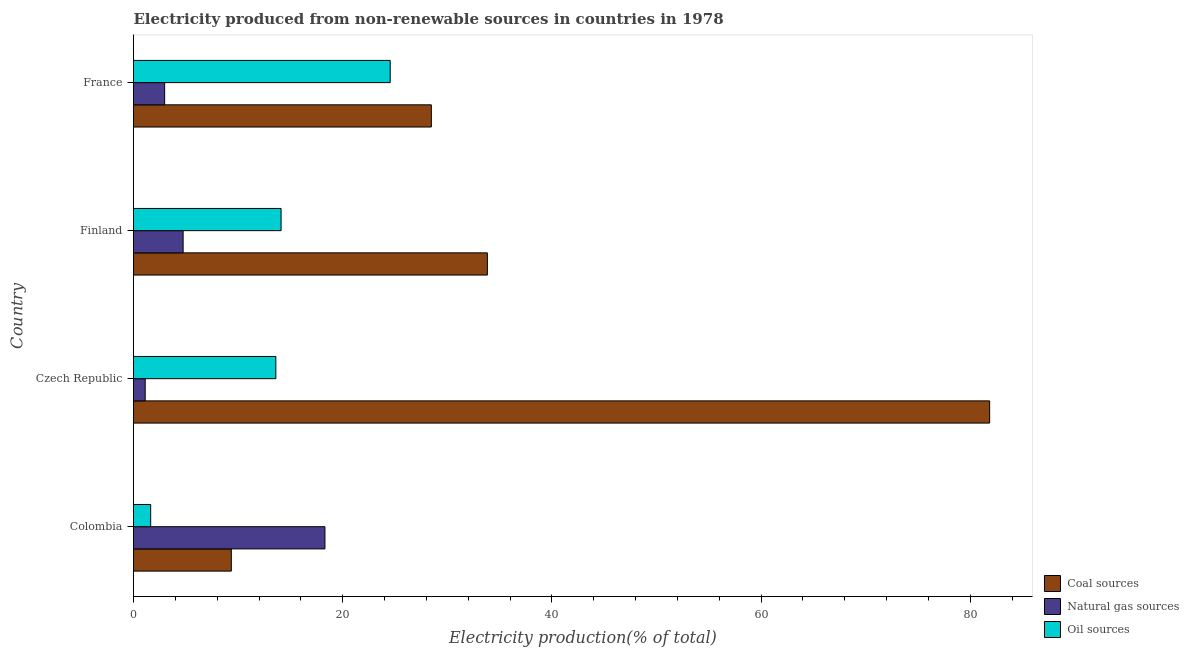How many different coloured bars are there?
Keep it short and to the point. 3. How many groups of bars are there?
Provide a succinct answer. 4. Are the number of bars per tick equal to the number of legend labels?
Keep it short and to the point. Yes. Are the number of bars on each tick of the Y-axis equal?
Ensure brevity in your answer.  Yes. How many bars are there on the 3rd tick from the top?
Offer a terse response. 3. How many bars are there on the 1st tick from the bottom?
Your response must be concise. 3. What is the label of the 1st group of bars from the top?
Offer a terse response. France. What is the percentage of electricity produced by oil sources in France?
Provide a succinct answer. 24.54. Across all countries, what is the maximum percentage of electricity produced by coal?
Ensure brevity in your answer.  81.86. Across all countries, what is the minimum percentage of electricity produced by natural gas?
Your answer should be compact. 1.12. In which country was the percentage of electricity produced by natural gas maximum?
Provide a short and direct response. Colombia. What is the total percentage of electricity produced by coal in the graph?
Offer a terse response. 153.53. What is the difference between the percentage of electricity produced by oil sources in Colombia and that in Czech Republic?
Give a very brief answer. -11.97. What is the difference between the percentage of electricity produced by natural gas in Colombia and the percentage of electricity produced by oil sources in France?
Give a very brief answer. -6.24. What is the average percentage of electricity produced by coal per country?
Your answer should be compact. 38.38. What is the difference between the percentage of electricity produced by oil sources and percentage of electricity produced by coal in Colombia?
Keep it short and to the point. -7.71. What is the ratio of the percentage of electricity produced by oil sources in Czech Republic to that in Finland?
Your response must be concise. 0.96. Is the percentage of electricity produced by natural gas in Colombia less than that in Finland?
Make the answer very short. No. What is the difference between the highest and the second highest percentage of electricity produced by natural gas?
Offer a very short reply. 13.56. What is the difference between the highest and the lowest percentage of electricity produced by coal?
Your answer should be very brief. 72.51. Is the sum of the percentage of electricity produced by oil sources in Colombia and Czech Republic greater than the maximum percentage of electricity produced by natural gas across all countries?
Provide a short and direct response. No. What does the 3rd bar from the top in Finland represents?
Provide a succinct answer. Coal sources. What does the 3rd bar from the bottom in Colombia represents?
Offer a very short reply. Oil sources. Is it the case that in every country, the sum of the percentage of electricity produced by coal and percentage of electricity produced by natural gas is greater than the percentage of electricity produced by oil sources?
Offer a terse response. Yes. What is the difference between two consecutive major ticks on the X-axis?
Provide a succinct answer. 20. Are the values on the major ticks of X-axis written in scientific E-notation?
Your answer should be compact. No. What is the title of the graph?
Offer a terse response. Electricity produced from non-renewable sources in countries in 1978. What is the label or title of the Y-axis?
Your response must be concise. Country. What is the Electricity production(% of total) of Coal sources in Colombia?
Your answer should be compact. 9.35. What is the Electricity production(% of total) in Natural gas sources in Colombia?
Keep it short and to the point. 18.3. What is the Electricity production(% of total) in Oil sources in Colombia?
Keep it short and to the point. 1.64. What is the Electricity production(% of total) in Coal sources in Czech Republic?
Make the answer very short. 81.86. What is the Electricity production(% of total) of Natural gas sources in Czech Republic?
Give a very brief answer. 1.12. What is the Electricity production(% of total) of Oil sources in Czech Republic?
Offer a very short reply. 13.61. What is the Electricity production(% of total) in Coal sources in Finland?
Offer a terse response. 33.84. What is the Electricity production(% of total) in Natural gas sources in Finland?
Provide a succinct answer. 4.74. What is the Electricity production(% of total) of Oil sources in Finland?
Your response must be concise. 14.11. What is the Electricity production(% of total) of Coal sources in France?
Provide a short and direct response. 28.48. What is the Electricity production(% of total) of Natural gas sources in France?
Keep it short and to the point. 2.98. What is the Electricity production(% of total) in Oil sources in France?
Your answer should be compact. 24.54. Across all countries, what is the maximum Electricity production(% of total) in Coal sources?
Offer a very short reply. 81.86. Across all countries, what is the maximum Electricity production(% of total) of Natural gas sources?
Provide a succinct answer. 18.3. Across all countries, what is the maximum Electricity production(% of total) of Oil sources?
Offer a very short reply. 24.54. Across all countries, what is the minimum Electricity production(% of total) in Coal sources?
Offer a terse response. 9.35. Across all countries, what is the minimum Electricity production(% of total) in Natural gas sources?
Make the answer very short. 1.12. Across all countries, what is the minimum Electricity production(% of total) in Oil sources?
Ensure brevity in your answer.  1.64. What is the total Electricity production(% of total) of Coal sources in the graph?
Keep it short and to the point. 153.53. What is the total Electricity production(% of total) of Natural gas sources in the graph?
Offer a terse response. 27.14. What is the total Electricity production(% of total) of Oil sources in the graph?
Your answer should be compact. 53.91. What is the difference between the Electricity production(% of total) of Coal sources in Colombia and that in Czech Republic?
Provide a succinct answer. -72.51. What is the difference between the Electricity production(% of total) of Natural gas sources in Colombia and that in Czech Republic?
Provide a succinct answer. 17.19. What is the difference between the Electricity production(% of total) in Oil sources in Colombia and that in Czech Republic?
Make the answer very short. -11.97. What is the difference between the Electricity production(% of total) of Coal sources in Colombia and that in Finland?
Provide a short and direct response. -24.48. What is the difference between the Electricity production(% of total) in Natural gas sources in Colombia and that in Finland?
Offer a terse response. 13.56. What is the difference between the Electricity production(% of total) in Oil sources in Colombia and that in Finland?
Ensure brevity in your answer.  -12.47. What is the difference between the Electricity production(% of total) of Coal sources in Colombia and that in France?
Your answer should be compact. -19.12. What is the difference between the Electricity production(% of total) of Natural gas sources in Colombia and that in France?
Your answer should be very brief. 15.33. What is the difference between the Electricity production(% of total) in Oil sources in Colombia and that in France?
Offer a very short reply. -22.9. What is the difference between the Electricity production(% of total) of Coal sources in Czech Republic and that in Finland?
Provide a succinct answer. 48.03. What is the difference between the Electricity production(% of total) in Natural gas sources in Czech Republic and that in Finland?
Your response must be concise. -3.63. What is the difference between the Electricity production(% of total) in Oil sources in Czech Republic and that in Finland?
Offer a very short reply. -0.5. What is the difference between the Electricity production(% of total) of Coal sources in Czech Republic and that in France?
Offer a terse response. 53.38. What is the difference between the Electricity production(% of total) in Natural gas sources in Czech Republic and that in France?
Your response must be concise. -1.86. What is the difference between the Electricity production(% of total) of Oil sources in Czech Republic and that in France?
Keep it short and to the point. -10.93. What is the difference between the Electricity production(% of total) in Coal sources in Finland and that in France?
Offer a very short reply. 5.36. What is the difference between the Electricity production(% of total) in Natural gas sources in Finland and that in France?
Make the answer very short. 1.77. What is the difference between the Electricity production(% of total) in Oil sources in Finland and that in France?
Give a very brief answer. -10.43. What is the difference between the Electricity production(% of total) of Coal sources in Colombia and the Electricity production(% of total) of Natural gas sources in Czech Republic?
Offer a very short reply. 8.24. What is the difference between the Electricity production(% of total) in Coal sources in Colombia and the Electricity production(% of total) in Oil sources in Czech Republic?
Keep it short and to the point. -4.26. What is the difference between the Electricity production(% of total) of Natural gas sources in Colombia and the Electricity production(% of total) of Oil sources in Czech Republic?
Offer a terse response. 4.69. What is the difference between the Electricity production(% of total) in Coal sources in Colombia and the Electricity production(% of total) in Natural gas sources in Finland?
Offer a very short reply. 4.61. What is the difference between the Electricity production(% of total) in Coal sources in Colombia and the Electricity production(% of total) in Oil sources in Finland?
Give a very brief answer. -4.76. What is the difference between the Electricity production(% of total) of Natural gas sources in Colombia and the Electricity production(% of total) of Oil sources in Finland?
Your response must be concise. 4.19. What is the difference between the Electricity production(% of total) in Coal sources in Colombia and the Electricity production(% of total) in Natural gas sources in France?
Your response must be concise. 6.38. What is the difference between the Electricity production(% of total) of Coal sources in Colombia and the Electricity production(% of total) of Oil sources in France?
Give a very brief answer. -15.19. What is the difference between the Electricity production(% of total) of Natural gas sources in Colombia and the Electricity production(% of total) of Oil sources in France?
Ensure brevity in your answer.  -6.24. What is the difference between the Electricity production(% of total) in Coal sources in Czech Republic and the Electricity production(% of total) in Natural gas sources in Finland?
Your answer should be compact. 77.12. What is the difference between the Electricity production(% of total) of Coal sources in Czech Republic and the Electricity production(% of total) of Oil sources in Finland?
Your answer should be very brief. 67.75. What is the difference between the Electricity production(% of total) of Natural gas sources in Czech Republic and the Electricity production(% of total) of Oil sources in Finland?
Offer a terse response. -12.99. What is the difference between the Electricity production(% of total) in Coal sources in Czech Republic and the Electricity production(% of total) in Natural gas sources in France?
Make the answer very short. 78.89. What is the difference between the Electricity production(% of total) in Coal sources in Czech Republic and the Electricity production(% of total) in Oil sources in France?
Make the answer very short. 57.32. What is the difference between the Electricity production(% of total) of Natural gas sources in Czech Republic and the Electricity production(% of total) of Oil sources in France?
Your answer should be very brief. -23.43. What is the difference between the Electricity production(% of total) in Coal sources in Finland and the Electricity production(% of total) in Natural gas sources in France?
Your response must be concise. 30.86. What is the difference between the Electricity production(% of total) in Coal sources in Finland and the Electricity production(% of total) in Oil sources in France?
Keep it short and to the point. 9.29. What is the difference between the Electricity production(% of total) of Natural gas sources in Finland and the Electricity production(% of total) of Oil sources in France?
Your answer should be compact. -19.8. What is the average Electricity production(% of total) in Coal sources per country?
Provide a short and direct response. 38.38. What is the average Electricity production(% of total) in Natural gas sources per country?
Offer a terse response. 6.79. What is the average Electricity production(% of total) in Oil sources per country?
Make the answer very short. 13.48. What is the difference between the Electricity production(% of total) in Coal sources and Electricity production(% of total) in Natural gas sources in Colombia?
Your answer should be very brief. -8.95. What is the difference between the Electricity production(% of total) in Coal sources and Electricity production(% of total) in Oil sources in Colombia?
Your answer should be very brief. 7.71. What is the difference between the Electricity production(% of total) of Natural gas sources and Electricity production(% of total) of Oil sources in Colombia?
Offer a very short reply. 16.66. What is the difference between the Electricity production(% of total) in Coal sources and Electricity production(% of total) in Natural gas sources in Czech Republic?
Your answer should be very brief. 80.74. What is the difference between the Electricity production(% of total) in Coal sources and Electricity production(% of total) in Oil sources in Czech Republic?
Your response must be concise. 68.25. What is the difference between the Electricity production(% of total) of Natural gas sources and Electricity production(% of total) of Oil sources in Czech Republic?
Provide a succinct answer. -12.49. What is the difference between the Electricity production(% of total) in Coal sources and Electricity production(% of total) in Natural gas sources in Finland?
Ensure brevity in your answer.  29.09. What is the difference between the Electricity production(% of total) of Coal sources and Electricity production(% of total) of Oil sources in Finland?
Make the answer very short. 19.72. What is the difference between the Electricity production(% of total) of Natural gas sources and Electricity production(% of total) of Oil sources in Finland?
Provide a short and direct response. -9.37. What is the difference between the Electricity production(% of total) of Coal sources and Electricity production(% of total) of Natural gas sources in France?
Your answer should be very brief. 25.5. What is the difference between the Electricity production(% of total) of Coal sources and Electricity production(% of total) of Oil sources in France?
Give a very brief answer. 3.93. What is the difference between the Electricity production(% of total) of Natural gas sources and Electricity production(% of total) of Oil sources in France?
Keep it short and to the point. -21.57. What is the ratio of the Electricity production(% of total) in Coal sources in Colombia to that in Czech Republic?
Ensure brevity in your answer.  0.11. What is the ratio of the Electricity production(% of total) in Natural gas sources in Colombia to that in Czech Republic?
Offer a very short reply. 16.37. What is the ratio of the Electricity production(% of total) in Oil sources in Colombia to that in Czech Republic?
Ensure brevity in your answer.  0.12. What is the ratio of the Electricity production(% of total) in Coal sources in Colombia to that in Finland?
Provide a short and direct response. 0.28. What is the ratio of the Electricity production(% of total) in Natural gas sources in Colombia to that in Finland?
Your answer should be compact. 3.86. What is the ratio of the Electricity production(% of total) of Oil sources in Colombia to that in Finland?
Your answer should be very brief. 0.12. What is the ratio of the Electricity production(% of total) in Coal sources in Colombia to that in France?
Your response must be concise. 0.33. What is the ratio of the Electricity production(% of total) in Natural gas sources in Colombia to that in France?
Keep it short and to the point. 6.15. What is the ratio of the Electricity production(% of total) in Oil sources in Colombia to that in France?
Give a very brief answer. 0.07. What is the ratio of the Electricity production(% of total) in Coal sources in Czech Republic to that in Finland?
Provide a succinct answer. 2.42. What is the ratio of the Electricity production(% of total) of Natural gas sources in Czech Republic to that in Finland?
Your answer should be very brief. 0.24. What is the ratio of the Electricity production(% of total) of Oil sources in Czech Republic to that in Finland?
Provide a short and direct response. 0.96. What is the ratio of the Electricity production(% of total) in Coal sources in Czech Republic to that in France?
Provide a short and direct response. 2.87. What is the ratio of the Electricity production(% of total) of Natural gas sources in Czech Republic to that in France?
Your answer should be very brief. 0.38. What is the ratio of the Electricity production(% of total) in Oil sources in Czech Republic to that in France?
Ensure brevity in your answer.  0.55. What is the ratio of the Electricity production(% of total) in Coal sources in Finland to that in France?
Offer a terse response. 1.19. What is the ratio of the Electricity production(% of total) of Natural gas sources in Finland to that in France?
Your answer should be very brief. 1.59. What is the ratio of the Electricity production(% of total) of Oil sources in Finland to that in France?
Keep it short and to the point. 0.57. What is the difference between the highest and the second highest Electricity production(% of total) of Coal sources?
Your answer should be very brief. 48.03. What is the difference between the highest and the second highest Electricity production(% of total) of Natural gas sources?
Offer a terse response. 13.56. What is the difference between the highest and the second highest Electricity production(% of total) of Oil sources?
Give a very brief answer. 10.43. What is the difference between the highest and the lowest Electricity production(% of total) in Coal sources?
Keep it short and to the point. 72.51. What is the difference between the highest and the lowest Electricity production(% of total) of Natural gas sources?
Provide a succinct answer. 17.19. What is the difference between the highest and the lowest Electricity production(% of total) in Oil sources?
Ensure brevity in your answer.  22.9. 